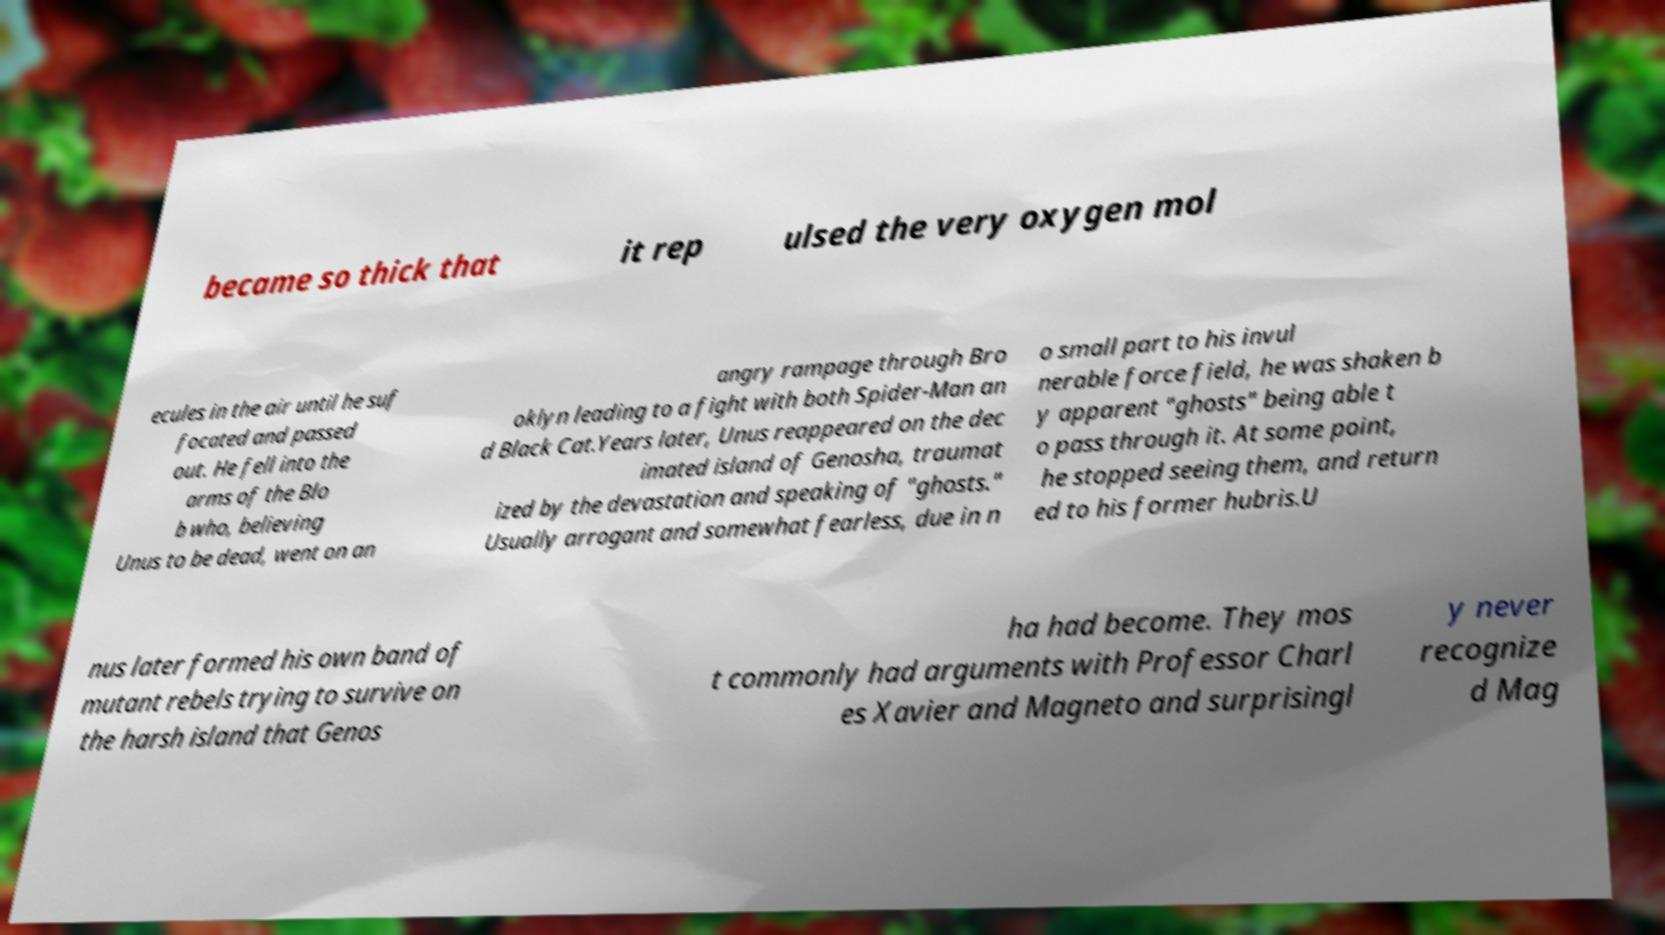There's text embedded in this image that I need extracted. Can you transcribe it verbatim? became so thick that it rep ulsed the very oxygen mol ecules in the air until he suf focated and passed out. He fell into the arms of the Blo b who, believing Unus to be dead, went on an angry rampage through Bro oklyn leading to a fight with both Spider-Man an d Black Cat.Years later, Unus reappeared on the dec imated island of Genosha, traumat ized by the devastation and speaking of "ghosts." Usually arrogant and somewhat fearless, due in n o small part to his invul nerable force field, he was shaken b y apparent "ghosts" being able t o pass through it. At some point, he stopped seeing them, and return ed to his former hubris.U nus later formed his own band of mutant rebels trying to survive on the harsh island that Genos ha had become. They mos t commonly had arguments with Professor Charl es Xavier and Magneto and surprisingl y never recognize d Mag 